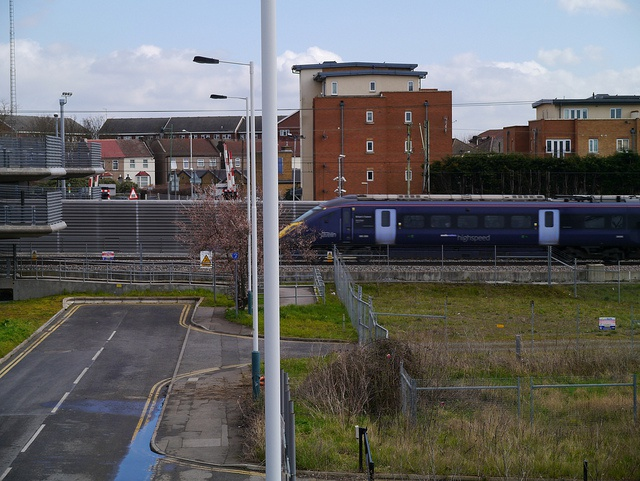Describe the objects in this image and their specific colors. I can see a train in lightblue, black, navy, and gray tones in this image. 